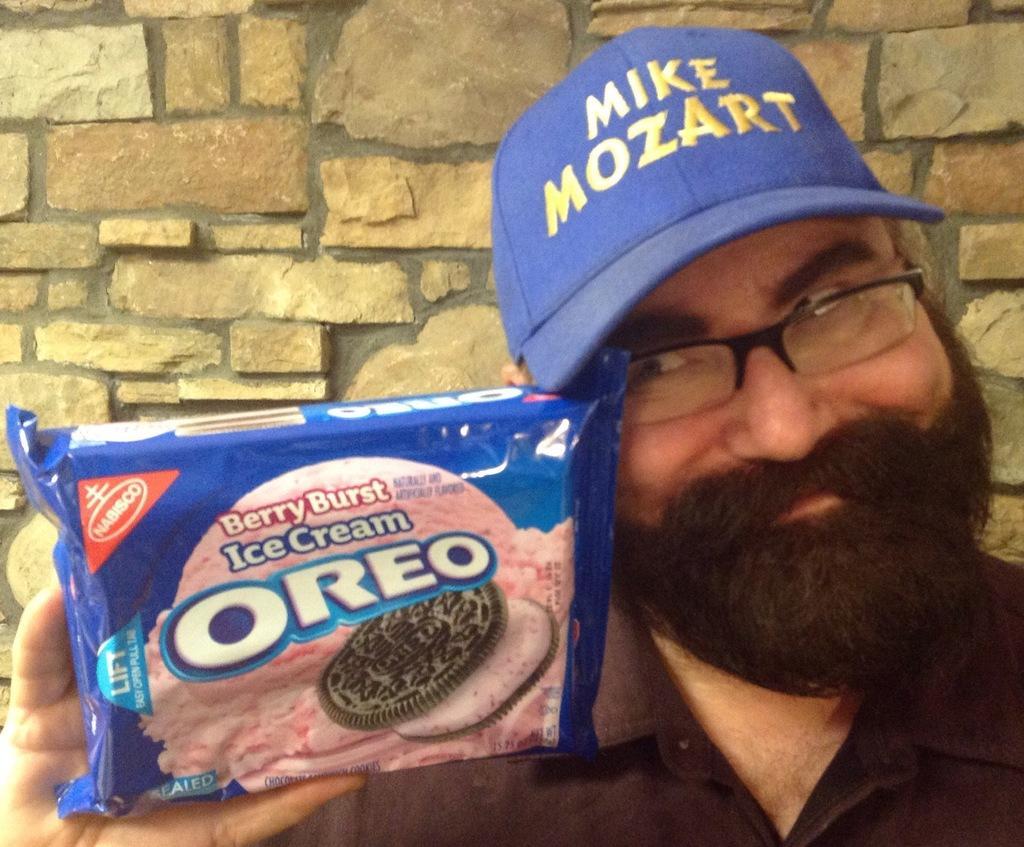Describe this image in one or two sentences. In this image there is a man on the right side who is showing the biscuit packet, by holding it with his hand. In the background there is a wall. The man is wearing the spectacles and a cap. 